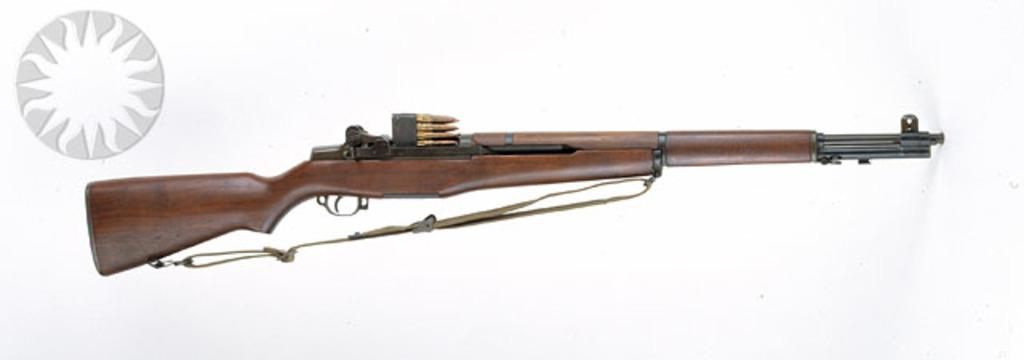What object is the main focus of the image? There is a gun in the image. What materials were used to make the gun? The gun is made of wood and iron. Are there any additional items related to the gun in the image? Yes, there are bullets on top of the gun. What type of crayon is the queen using to draw a creature in the image? There is no crayon, queen, or creature present in the image; it only features a gun made of wood and iron with bullets on top. 